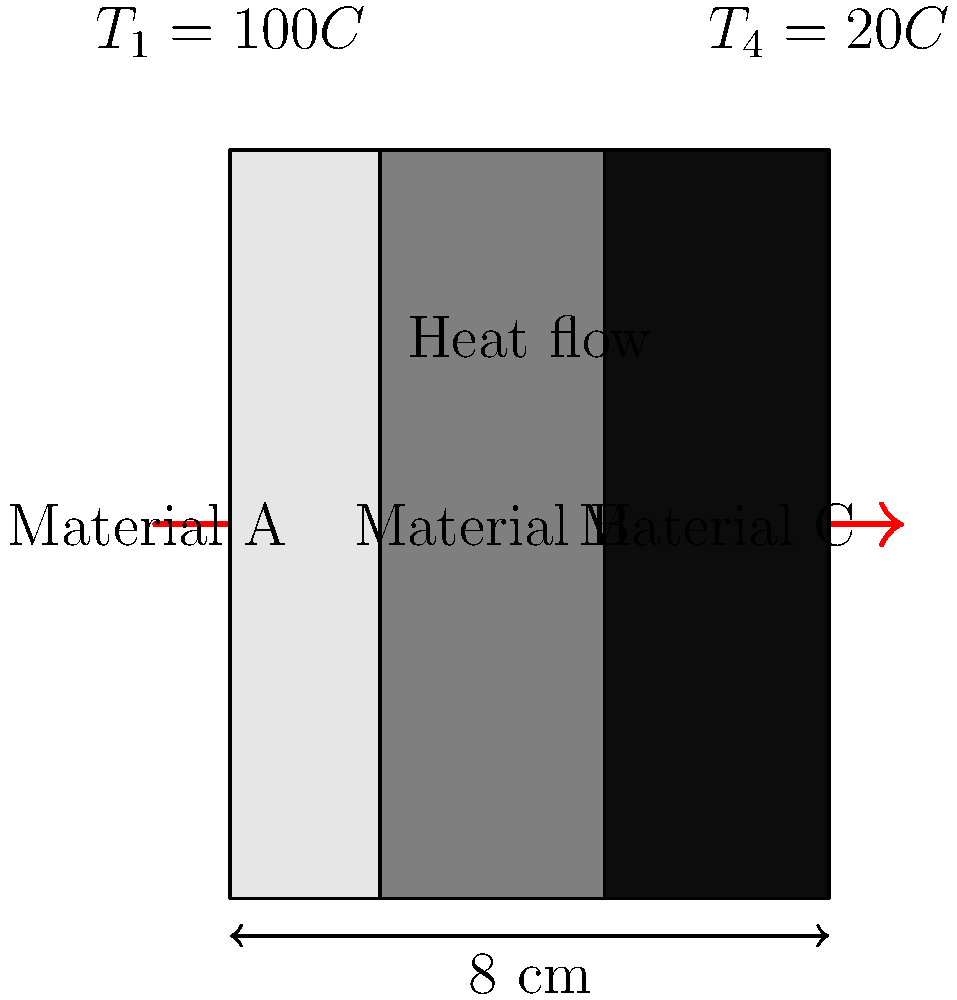As an illustrator learning about heat transfer, you're tasked with creating a visual representation of heat flow through a composite wall. The wall consists of three layers of different materials (A, B, and C) with a total thickness of 8 cm. The temperature on the left side is 100°C, and on the right side is 20°C. If the thermal conductivities of materials A, B, and C are 0.5 W/(m·K), 0.3 W/(m·K), and 0.2 W/(m·K) respectively, calculate the rate of heat transfer per unit area through the wall. Let's approach this step-by-step:

1) First, we need to understand the heat transfer equation for composite walls:

   $$ q = \frac{T_1 - T_4}{\frac{L_1}{k_1} + \frac{L_2}{k_2} + \frac{L_3}{k_3}} $$

   Where $q$ is the heat transfer rate per unit area, $T_1$ and $T_4$ are the temperatures on either side, $L_i$ is the thickness of each layer, and $k_i$ is the thermal conductivity of each material.

2) We know:
   - $T_1 = 100°C$, $T_4 = 20°C$
   - Total thickness = 8 cm = 0.08 m
   - $k_A = 0.5$ W/(m·K), $k_B = 0.3$ W/(m·K), $k_C = 0.2$ W/(m·K)

3) We need to determine the thickness of each layer. From the image, we can see that:
   - $L_A = 2$ cm = 0.02 m
   - $L_B = 3$ cm = 0.03 m
   - $L_C = 3$ cm = 0.03 m

4) Now we can substitute these values into our equation:

   $$ q = \frac{100°C - 20°C}{\frac{0.02 m}{0.5 W/(m·K)} + \frac{0.03 m}{0.3 W/(m·K)} + \frac{0.03 m}{0.2 W/(m·K)}} $$

5) Simplify:

   $$ q = \frac{80°C}{0.04 + 0.1 + 0.15} m·K/W = \frac{80}{0.29} W/m^2 $$

6) Calculate the final result:

   $$ q \approx 275.86 W/m^2 $$
Answer: 275.86 W/m² 